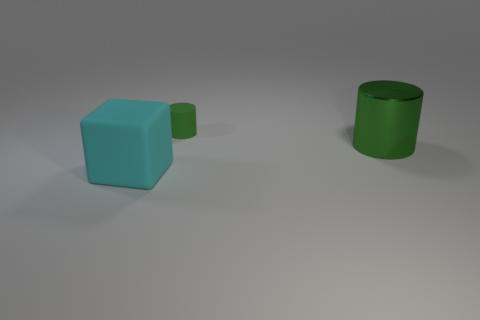Add 3 small objects. How many objects exist? 6 Subtract all cylinders. How many objects are left? 1 Subtract 0 blue spheres. How many objects are left? 3 Subtract all tiny rubber cylinders. Subtract all big green metal cylinders. How many objects are left? 1 Add 3 small green cylinders. How many small green cylinders are left? 4 Add 2 cylinders. How many cylinders exist? 4 